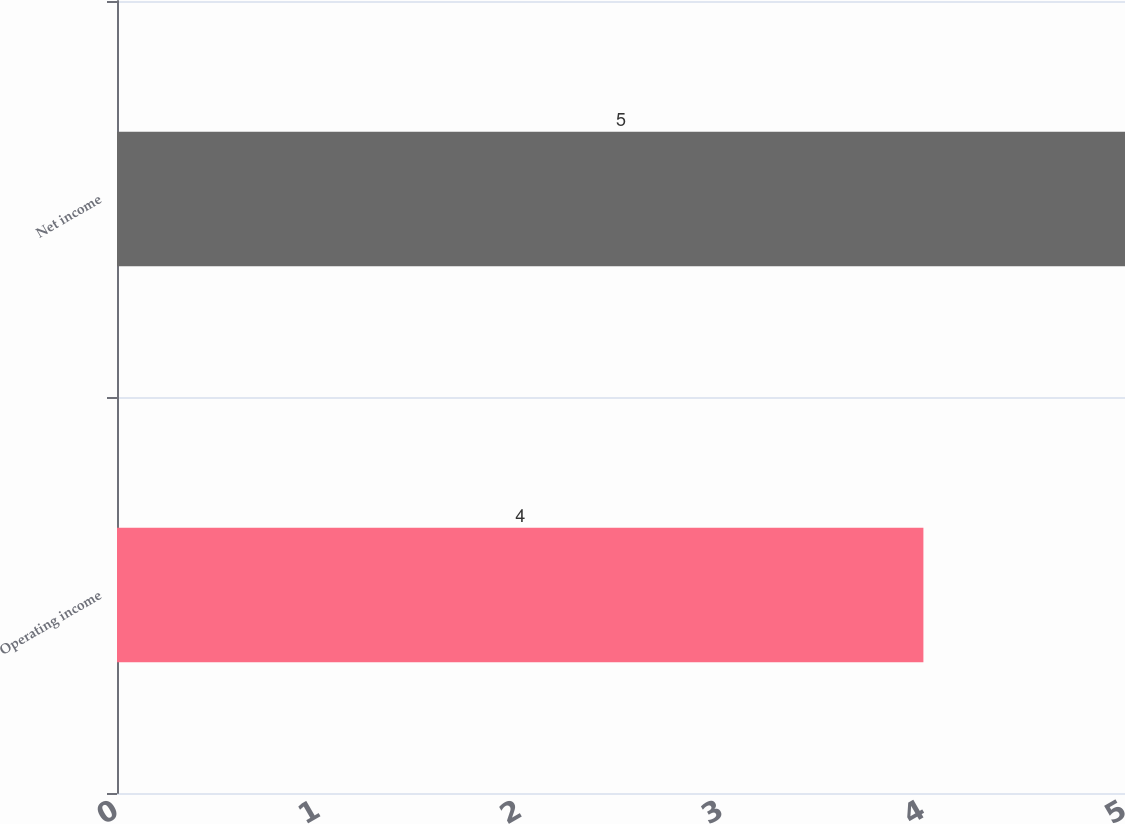Convert chart. <chart><loc_0><loc_0><loc_500><loc_500><bar_chart><fcel>Operating income<fcel>Net income<nl><fcel>4<fcel>5<nl></chart> 